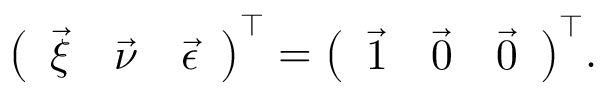<formula> <loc_0><loc_0><loc_500><loc_500>\left ( \begin{array} { l l l } { \vec { \xi } } & { \vec { \nu } } & { \vec { \epsilon } } \end{array} \right ) ^ { \top } = \left ( \begin{array} { l l l } { \vec { 1 } } & { \vec { 0 } } & { \vec { 0 } } \end{array} \right ) ^ { \top } \, .</formula> 